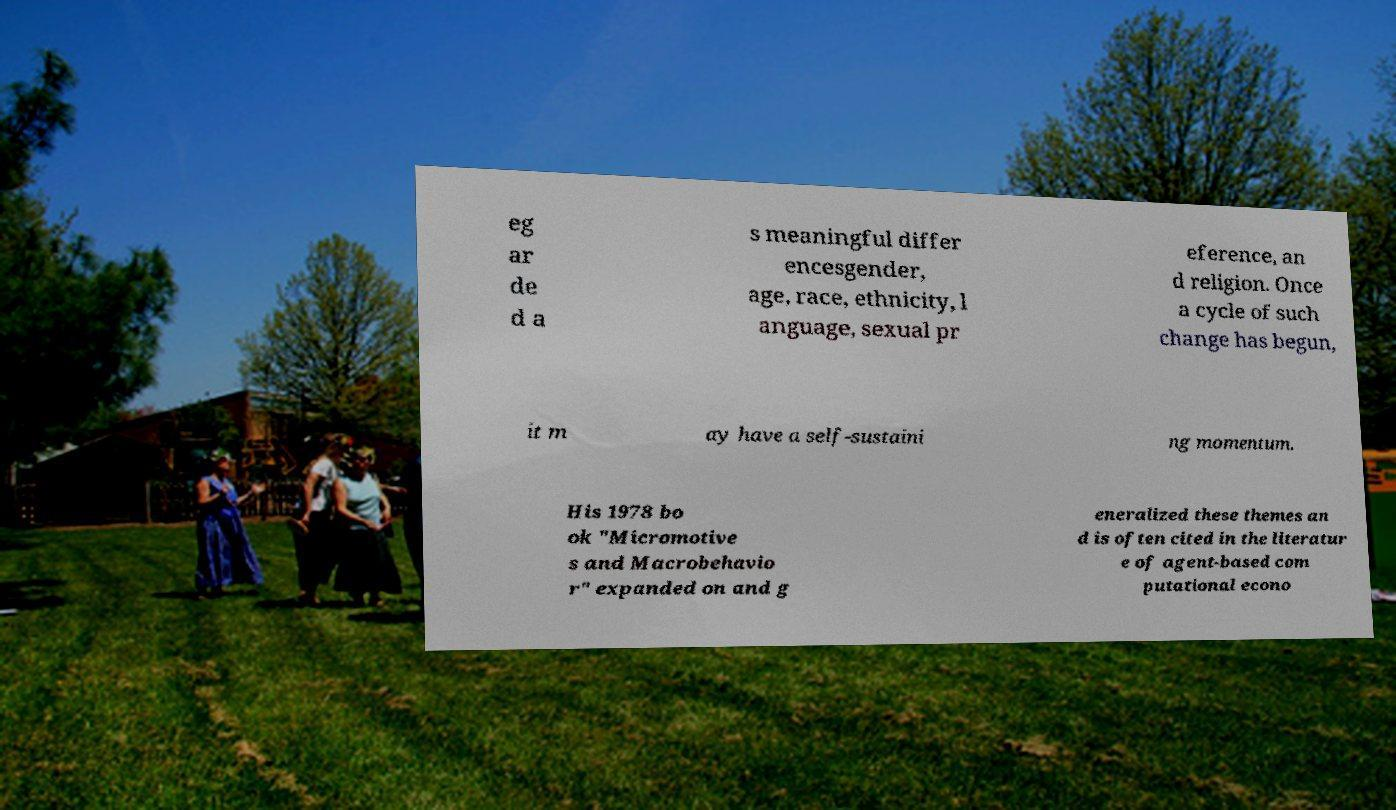Please read and relay the text visible in this image. What does it say? eg ar de d a s meaningful differ encesgender, age, race, ethnicity, l anguage, sexual pr eference, an d religion. Once a cycle of such change has begun, it m ay have a self-sustaini ng momentum. His 1978 bo ok "Micromotive s and Macrobehavio r" expanded on and g eneralized these themes an d is often cited in the literatur e of agent-based com putational econo 